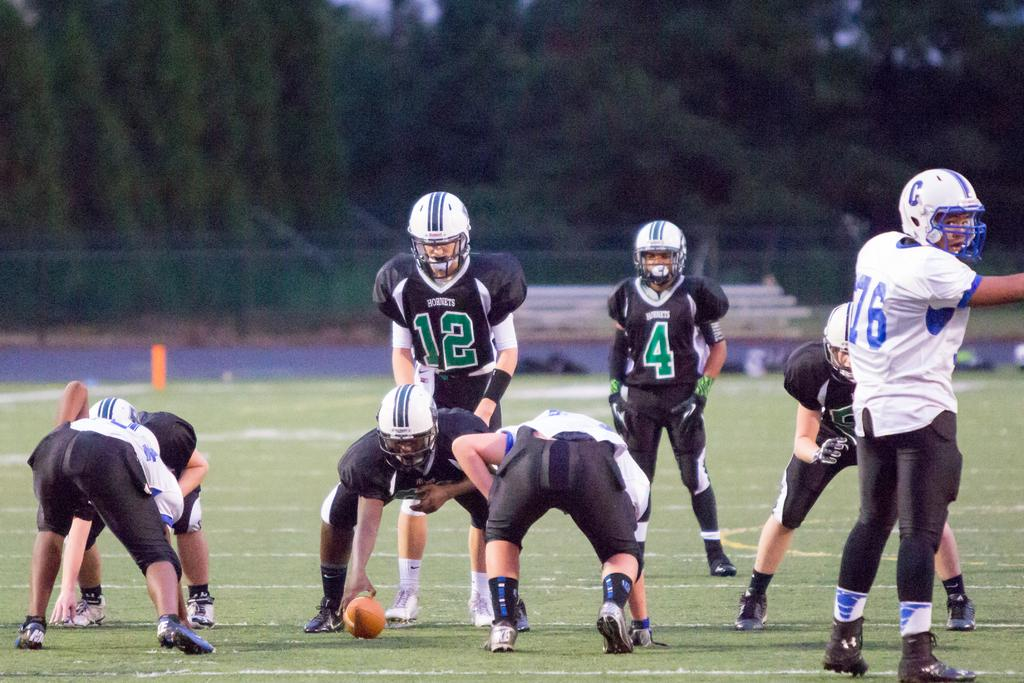How many people are in the image? There is a group of people in the image. What are the people wearing on their heads? The people are wearing helmets. Where are the people standing in the image? The people are standing on the ground. What object can be seen in the image besides the people? There is a ball in the image. What can be seen in the background of the image? There are trees in the background of the image. What type of crops is the farmer harvesting in the image? There is no farmer or crops present in the image; it features a group of people wearing helmets and standing on the ground. How many police officers are visible in the image? There are no police officers present in the image. 